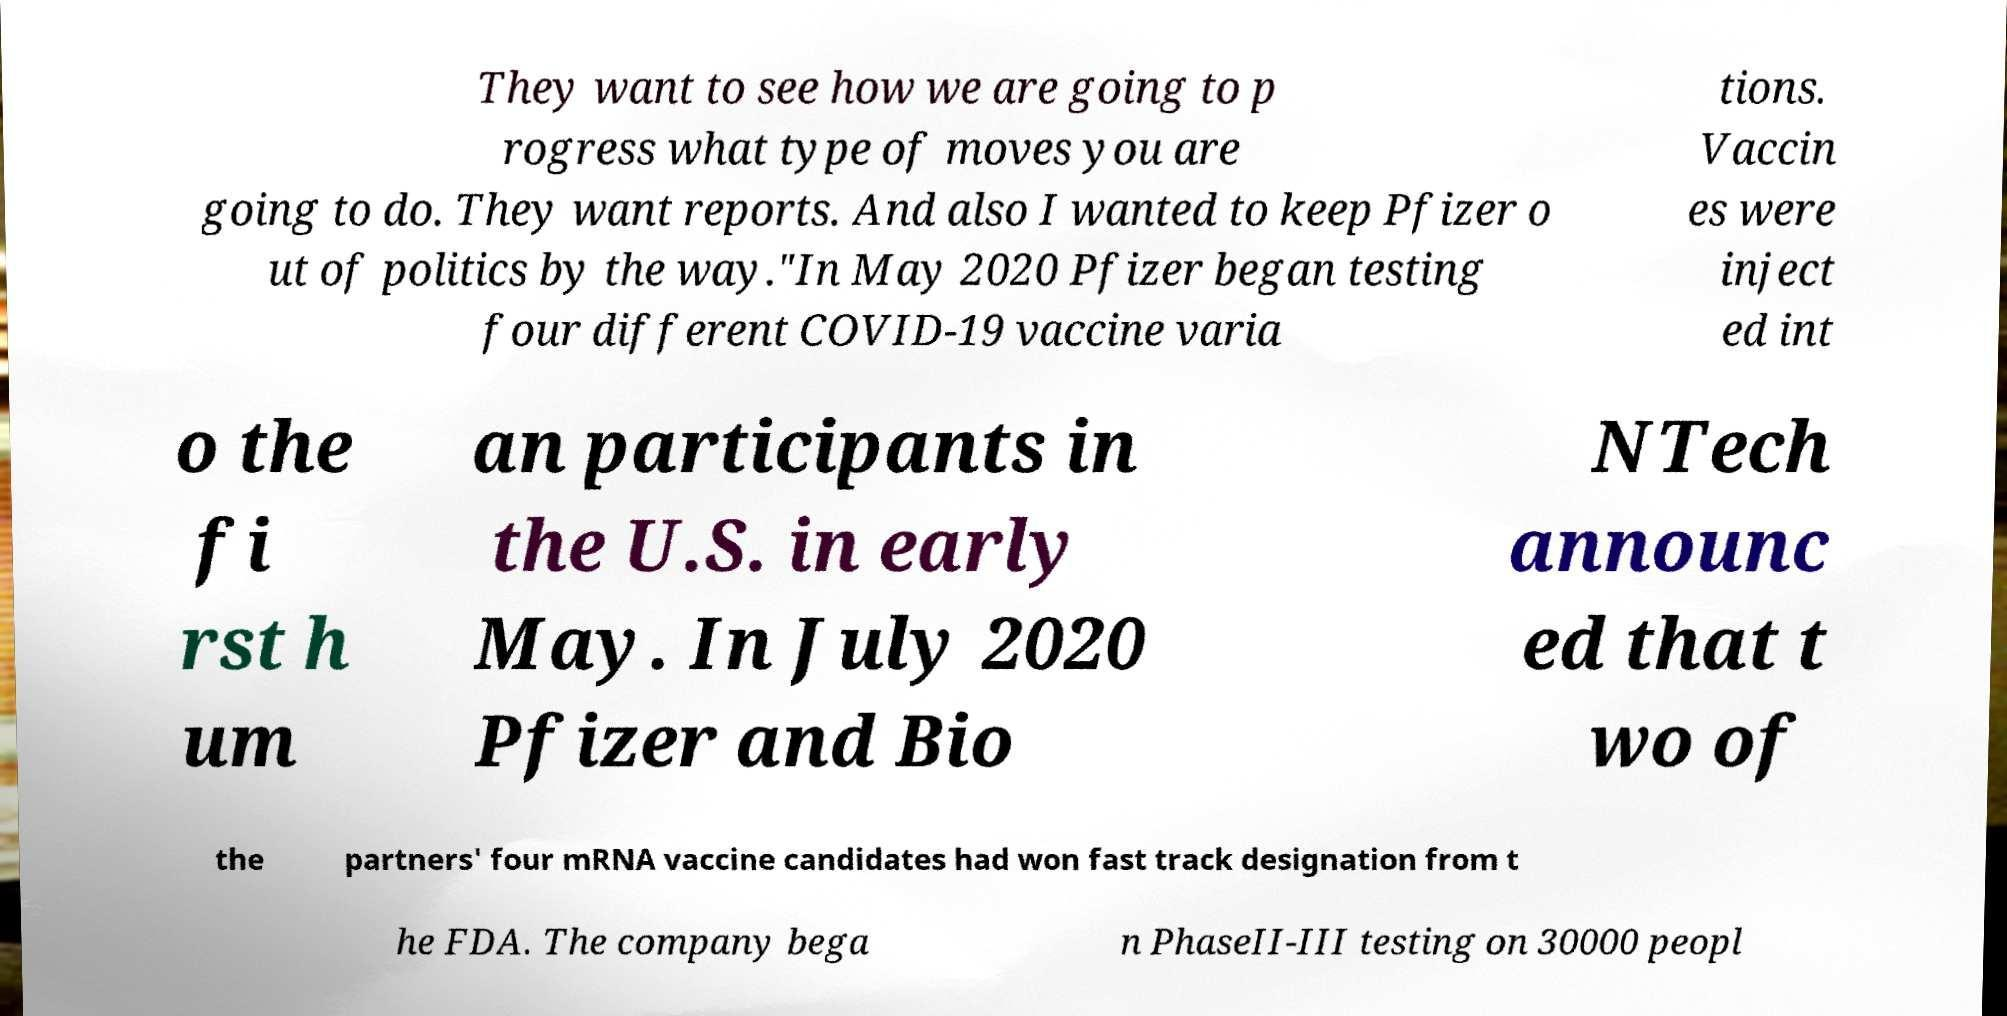Can you accurately transcribe the text from the provided image for me? They want to see how we are going to p rogress what type of moves you are going to do. They want reports. And also I wanted to keep Pfizer o ut of politics by the way."In May 2020 Pfizer began testing four different COVID-19 vaccine varia tions. Vaccin es were inject ed int o the fi rst h um an participants in the U.S. in early May. In July 2020 Pfizer and Bio NTech announc ed that t wo of the partners' four mRNA vaccine candidates had won fast track designation from t he FDA. The company bega n PhaseII-III testing on 30000 peopl 